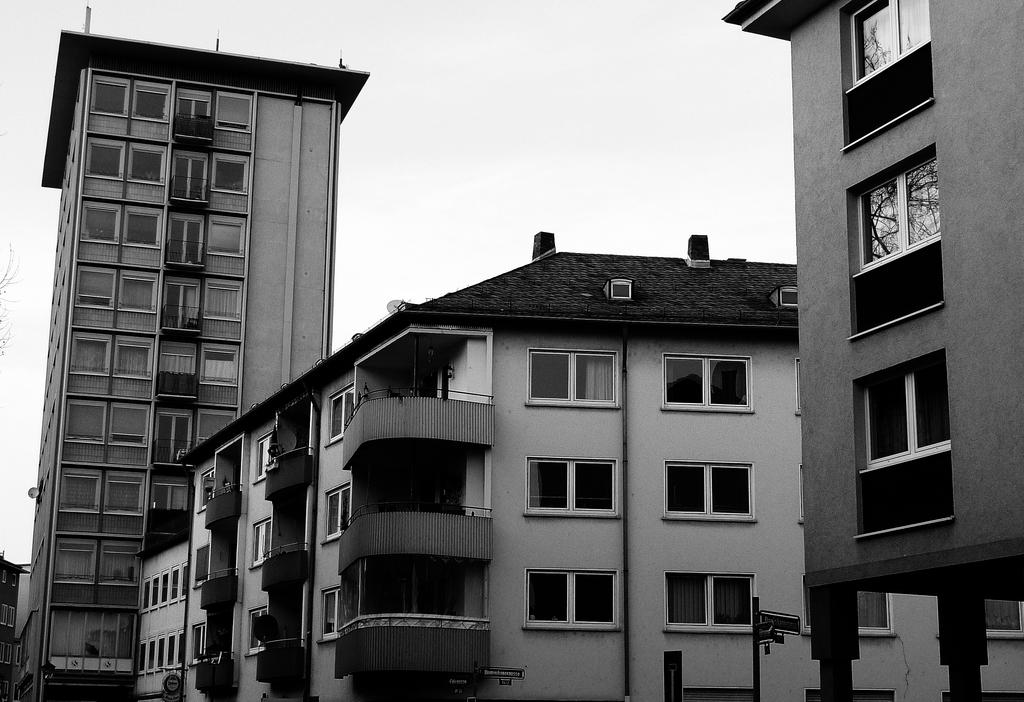What type of structures are present in the image? There are buildings in the image. What feature can be seen on the buildings? The buildings have glass windows. What part of the natural environment is visible in the image? The sky is visible in the image. What type of industry can be seen near the ocean in the image? There is no industry or ocean present in the image; it features buildings with glass windows and a visible sky. 